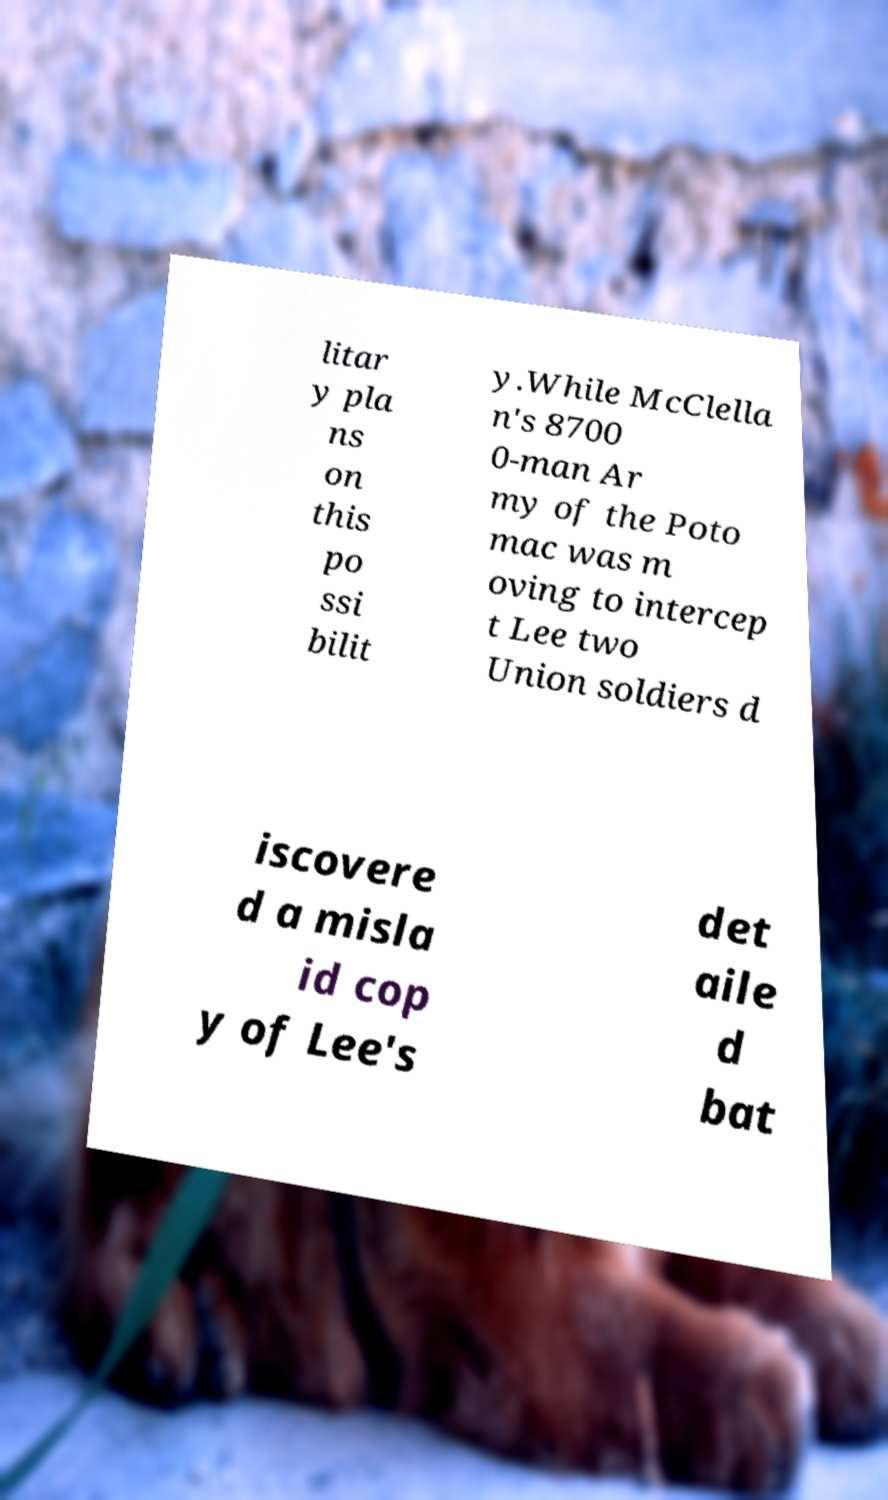I need the written content from this picture converted into text. Can you do that? litar y pla ns on this po ssi bilit y.While McClella n's 8700 0-man Ar my of the Poto mac was m oving to intercep t Lee two Union soldiers d iscovere d a misla id cop y of Lee's det aile d bat 